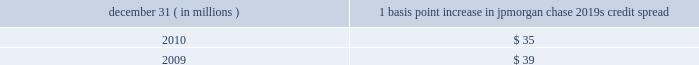Management 2019s discussion and analysis 144 jpmorgan chase & co./2010 annual report compared with $ 57 million for 2009 .
Decreases in cio and mort- gage banking var for 2010 were again driven by the decline in market volatility and position changes .
The decline in mortgage banking var at december 31 , 2010 , reflects management 2019s deci- sion to reduce risk given market volatility at the time .
The firm 2019s average ib and other var diversification benefit was $ 59 million or 37% ( 37 % ) of the sum for 2010 , compared with $ 82 million or 28% ( 28 % ) of the sum for 2009 .
The firm experienced an increase in the diversification benefit in 2010 as positions changed and correla- tions decreased .
In general , over the course of the year , var expo- sure can vary significantly as positions change , market volatility fluctuates and diversification benefits change .
Var back-testing the firm conducts daily back-testing of var against its market risk- related revenue , which is defined as the change in value of : princi- pal transactions revenue for ib and cio ( less private equity gains/losses and revenue from longer-term cio investments ) ; trading-related net interest income for ib , cio and mortgage bank- ing ; ib brokerage commissions , underwriting fees or other revenue ; revenue from syndicated lending facilities that the firm intends to distribute ; and mortgage fees and related income for the firm 2019s mortgage pipeline and warehouse loans , msrs , and all related hedges .
Daily firmwide market risk 2013related revenue excludes gains and losses from dva .
The following histogram illustrates the daily market risk 2013related gains and losses for ib , cio and mortgage banking positions for 2010 .
The chart shows that the firm posted market risk 2013related gains on 248 out of 261 days in this period , with 12 days exceeding $ 210 million .
The inset graph looks at those days on which the firm experienced losses and depicts the amount by which the 95% ( 95 % ) confidence-level var ex- ceeded the actual loss on each of those days .
During 2010 , losses were sustained on 13 days , none of which exceeded the var measure .
Daily ib and other market risk-related gains and losses ( 95% ( 95 % ) confidence-level var ) year ended december 31 , 2010 average daily revenue : $ 87 million $ in millions $ in millions daily ib and other var less market risk-related losses the table provides information about the gross sensitivity of dva to a one-basis-point increase in jpmorgan chase 2019s credit spreads .
This sensitivity represents the impact from a one-basis-point parallel shift in jpmorgan chase 2019s entire credit curve .
As credit curves do not typically move in a parallel fashion , the sensitivity multiplied by the change in spreads at a single maturity point may not be representative of the actual revenue recognized .
Debit valuation adjustment sensitivity 1 basis point increase in december 31 , ( in millions ) jpmorgan chase 2019s credit spread .

On what percent of trading days were there market gains above $ 210 million? 
Computations: (12 / 261)
Answer: 0.04598. 